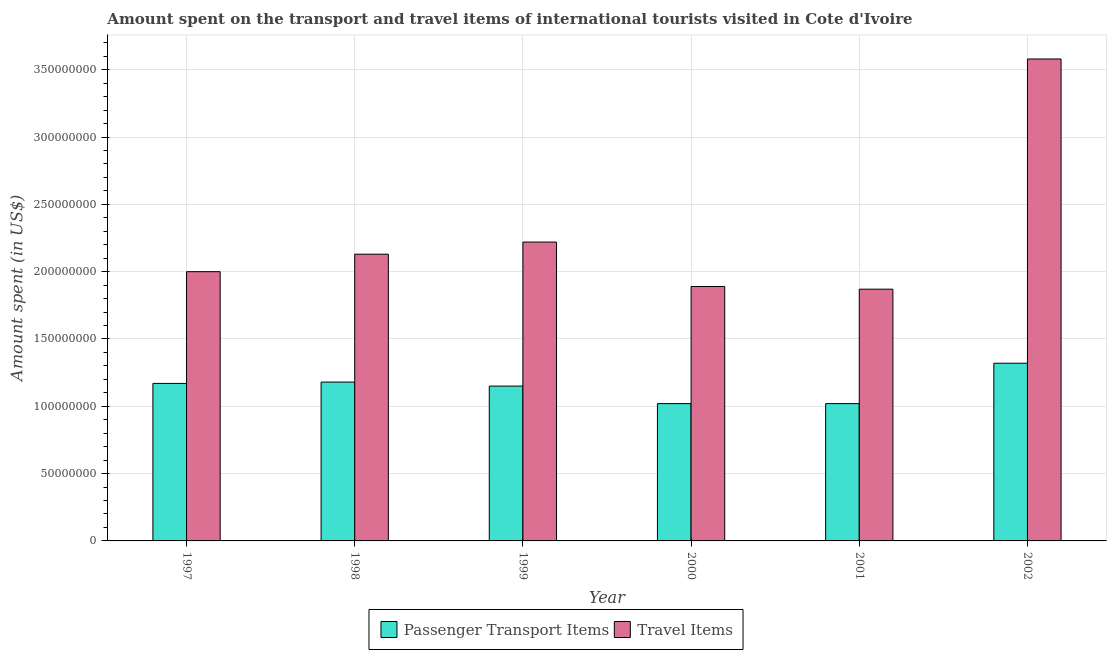How many different coloured bars are there?
Provide a succinct answer. 2. How many bars are there on the 1st tick from the right?
Keep it short and to the point. 2. What is the label of the 6th group of bars from the left?
Ensure brevity in your answer.  2002. What is the amount spent in travel items in 2002?
Your answer should be compact. 3.58e+08. Across all years, what is the maximum amount spent on passenger transport items?
Ensure brevity in your answer.  1.32e+08. Across all years, what is the minimum amount spent on passenger transport items?
Give a very brief answer. 1.02e+08. In which year was the amount spent on passenger transport items maximum?
Make the answer very short. 2002. In which year was the amount spent on passenger transport items minimum?
Ensure brevity in your answer.  2000. What is the total amount spent in travel items in the graph?
Provide a short and direct response. 1.37e+09. What is the difference between the amount spent on passenger transport items in 1997 and that in 1999?
Your response must be concise. 2.00e+06. What is the difference between the amount spent on passenger transport items in 2001 and the amount spent in travel items in 2002?
Offer a terse response. -3.00e+07. What is the average amount spent on passenger transport items per year?
Your answer should be compact. 1.14e+08. What is the ratio of the amount spent on passenger transport items in 1997 to that in 2000?
Provide a short and direct response. 1.15. What is the difference between the highest and the second highest amount spent on passenger transport items?
Your answer should be very brief. 1.40e+07. What is the difference between the highest and the lowest amount spent on passenger transport items?
Offer a very short reply. 3.00e+07. In how many years, is the amount spent in travel items greater than the average amount spent in travel items taken over all years?
Give a very brief answer. 1. What does the 1st bar from the left in 2001 represents?
Offer a very short reply. Passenger Transport Items. What does the 2nd bar from the right in 2001 represents?
Provide a succinct answer. Passenger Transport Items. How many bars are there?
Your answer should be compact. 12. Are all the bars in the graph horizontal?
Your answer should be very brief. No. How many years are there in the graph?
Your response must be concise. 6. What is the difference between two consecutive major ticks on the Y-axis?
Make the answer very short. 5.00e+07. Does the graph contain grids?
Ensure brevity in your answer.  Yes. Where does the legend appear in the graph?
Your response must be concise. Bottom center. How are the legend labels stacked?
Offer a terse response. Horizontal. What is the title of the graph?
Your response must be concise. Amount spent on the transport and travel items of international tourists visited in Cote d'Ivoire. Does "Time to import" appear as one of the legend labels in the graph?
Provide a succinct answer. No. What is the label or title of the Y-axis?
Keep it short and to the point. Amount spent (in US$). What is the Amount spent (in US$) in Passenger Transport Items in 1997?
Offer a terse response. 1.17e+08. What is the Amount spent (in US$) of Travel Items in 1997?
Keep it short and to the point. 2.00e+08. What is the Amount spent (in US$) of Passenger Transport Items in 1998?
Keep it short and to the point. 1.18e+08. What is the Amount spent (in US$) in Travel Items in 1998?
Ensure brevity in your answer.  2.13e+08. What is the Amount spent (in US$) of Passenger Transport Items in 1999?
Offer a terse response. 1.15e+08. What is the Amount spent (in US$) of Travel Items in 1999?
Offer a very short reply. 2.22e+08. What is the Amount spent (in US$) of Passenger Transport Items in 2000?
Give a very brief answer. 1.02e+08. What is the Amount spent (in US$) of Travel Items in 2000?
Make the answer very short. 1.89e+08. What is the Amount spent (in US$) of Passenger Transport Items in 2001?
Keep it short and to the point. 1.02e+08. What is the Amount spent (in US$) in Travel Items in 2001?
Offer a very short reply. 1.87e+08. What is the Amount spent (in US$) of Passenger Transport Items in 2002?
Your response must be concise. 1.32e+08. What is the Amount spent (in US$) of Travel Items in 2002?
Offer a terse response. 3.58e+08. Across all years, what is the maximum Amount spent (in US$) of Passenger Transport Items?
Offer a terse response. 1.32e+08. Across all years, what is the maximum Amount spent (in US$) of Travel Items?
Ensure brevity in your answer.  3.58e+08. Across all years, what is the minimum Amount spent (in US$) of Passenger Transport Items?
Give a very brief answer. 1.02e+08. Across all years, what is the minimum Amount spent (in US$) of Travel Items?
Provide a succinct answer. 1.87e+08. What is the total Amount spent (in US$) in Passenger Transport Items in the graph?
Provide a short and direct response. 6.86e+08. What is the total Amount spent (in US$) of Travel Items in the graph?
Offer a very short reply. 1.37e+09. What is the difference between the Amount spent (in US$) in Passenger Transport Items in 1997 and that in 1998?
Offer a very short reply. -1.00e+06. What is the difference between the Amount spent (in US$) in Travel Items in 1997 and that in 1998?
Your response must be concise. -1.30e+07. What is the difference between the Amount spent (in US$) of Passenger Transport Items in 1997 and that in 1999?
Give a very brief answer. 2.00e+06. What is the difference between the Amount spent (in US$) of Travel Items in 1997 and that in 1999?
Your answer should be compact. -2.20e+07. What is the difference between the Amount spent (in US$) of Passenger Transport Items in 1997 and that in 2000?
Keep it short and to the point. 1.50e+07. What is the difference between the Amount spent (in US$) of Travel Items in 1997 and that in 2000?
Your answer should be compact. 1.10e+07. What is the difference between the Amount spent (in US$) of Passenger Transport Items in 1997 and that in 2001?
Provide a short and direct response. 1.50e+07. What is the difference between the Amount spent (in US$) of Travel Items in 1997 and that in 2001?
Make the answer very short. 1.30e+07. What is the difference between the Amount spent (in US$) in Passenger Transport Items in 1997 and that in 2002?
Your response must be concise. -1.50e+07. What is the difference between the Amount spent (in US$) of Travel Items in 1997 and that in 2002?
Provide a short and direct response. -1.58e+08. What is the difference between the Amount spent (in US$) in Travel Items in 1998 and that in 1999?
Your answer should be compact. -9.00e+06. What is the difference between the Amount spent (in US$) of Passenger Transport Items in 1998 and that in 2000?
Provide a succinct answer. 1.60e+07. What is the difference between the Amount spent (in US$) of Travel Items in 1998 and that in 2000?
Ensure brevity in your answer.  2.40e+07. What is the difference between the Amount spent (in US$) of Passenger Transport Items in 1998 and that in 2001?
Provide a short and direct response. 1.60e+07. What is the difference between the Amount spent (in US$) of Travel Items in 1998 and that in 2001?
Keep it short and to the point. 2.60e+07. What is the difference between the Amount spent (in US$) in Passenger Transport Items in 1998 and that in 2002?
Ensure brevity in your answer.  -1.40e+07. What is the difference between the Amount spent (in US$) of Travel Items in 1998 and that in 2002?
Offer a terse response. -1.45e+08. What is the difference between the Amount spent (in US$) of Passenger Transport Items in 1999 and that in 2000?
Your answer should be compact. 1.30e+07. What is the difference between the Amount spent (in US$) in Travel Items in 1999 and that in 2000?
Your answer should be compact. 3.30e+07. What is the difference between the Amount spent (in US$) of Passenger Transport Items in 1999 and that in 2001?
Keep it short and to the point. 1.30e+07. What is the difference between the Amount spent (in US$) of Travel Items in 1999 and that in 2001?
Keep it short and to the point. 3.50e+07. What is the difference between the Amount spent (in US$) of Passenger Transport Items in 1999 and that in 2002?
Provide a succinct answer. -1.70e+07. What is the difference between the Amount spent (in US$) of Travel Items in 1999 and that in 2002?
Your answer should be very brief. -1.36e+08. What is the difference between the Amount spent (in US$) in Passenger Transport Items in 2000 and that in 2001?
Your answer should be compact. 0. What is the difference between the Amount spent (in US$) of Travel Items in 2000 and that in 2001?
Provide a succinct answer. 2.00e+06. What is the difference between the Amount spent (in US$) in Passenger Transport Items in 2000 and that in 2002?
Offer a very short reply. -3.00e+07. What is the difference between the Amount spent (in US$) of Travel Items in 2000 and that in 2002?
Your response must be concise. -1.69e+08. What is the difference between the Amount spent (in US$) of Passenger Transport Items in 2001 and that in 2002?
Your response must be concise. -3.00e+07. What is the difference between the Amount spent (in US$) of Travel Items in 2001 and that in 2002?
Make the answer very short. -1.71e+08. What is the difference between the Amount spent (in US$) of Passenger Transport Items in 1997 and the Amount spent (in US$) of Travel Items in 1998?
Keep it short and to the point. -9.60e+07. What is the difference between the Amount spent (in US$) of Passenger Transport Items in 1997 and the Amount spent (in US$) of Travel Items in 1999?
Keep it short and to the point. -1.05e+08. What is the difference between the Amount spent (in US$) of Passenger Transport Items in 1997 and the Amount spent (in US$) of Travel Items in 2000?
Your response must be concise. -7.20e+07. What is the difference between the Amount spent (in US$) in Passenger Transport Items in 1997 and the Amount spent (in US$) in Travel Items in 2001?
Ensure brevity in your answer.  -7.00e+07. What is the difference between the Amount spent (in US$) in Passenger Transport Items in 1997 and the Amount spent (in US$) in Travel Items in 2002?
Give a very brief answer. -2.41e+08. What is the difference between the Amount spent (in US$) in Passenger Transport Items in 1998 and the Amount spent (in US$) in Travel Items in 1999?
Provide a succinct answer. -1.04e+08. What is the difference between the Amount spent (in US$) in Passenger Transport Items in 1998 and the Amount spent (in US$) in Travel Items in 2000?
Make the answer very short. -7.10e+07. What is the difference between the Amount spent (in US$) of Passenger Transport Items in 1998 and the Amount spent (in US$) of Travel Items in 2001?
Provide a short and direct response. -6.90e+07. What is the difference between the Amount spent (in US$) of Passenger Transport Items in 1998 and the Amount spent (in US$) of Travel Items in 2002?
Provide a short and direct response. -2.40e+08. What is the difference between the Amount spent (in US$) of Passenger Transport Items in 1999 and the Amount spent (in US$) of Travel Items in 2000?
Offer a terse response. -7.40e+07. What is the difference between the Amount spent (in US$) in Passenger Transport Items in 1999 and the Amount spent (in US$) in Travel Items in 2001?
Ensure brevity in your answer.  -7.20e+07. What is the difference between the Amount spent (in US$) in Passenger Transport Items in 1999 and the Amount spent (in US$) in Travel Items in 2002?
Your answer should be very brief. -2.43e+08. What is the difference between the Amount spent (in US$) of Passenger Transport Items in 2000 and the Amount spent (in US$) of Travel Items in 2001?
Ensure brevity in your answer.  -8.50e+07. What is the difference between the Amount spent (in US$) of Passenger Transport Items in 2000 and the Amount spent (in US$) of Travel Items in 2002?
Give a very brief answer. -2.56e+08. What is the difference between the Amount spent (in US$) in Passenger Transport Items in 2001 and the Amount spent (in US$) in Travel Items in 2002?
Offer a very short reply. -2.56e+08. What is the average Amount spent (in US$) in Passenger Transport Items per year?
Give a very brief answer. 1.14e+08. What is the average Amount spent (in US$) in Travel Items per year?
Provide a short and direct response. 2.28e+08. In the year 1997, what is the difference between the Amount spent (in US$) in Passenger Transport Items and Amount spent (in US$) in Travel Items?
Your answer should be very brief. -8.30e+07. In the year 1998, what is the difference between the Amount spent (in US$) in Passenger Transport Items and Amount spent (in US$) in Travel Items?
Your answer should be compact. -9.50e+07. In the year 1999, what is the difference between the Amount spent (in US$) of Passenger Transport Items and Amount spent (in US$) of Travel Items?
Ensure brevity in your answer.  -1.07e+08. In the year 2000, what is the difference between the Amount spent (in US$) of Passenger Transport Items and Amount spent (in US$) of Travel Items?
Provide a short and direct response. -8.70e+07. In the year 2001, what is the difference between the Amount spent (in US$) of Passenger Transport Items and Amount spent (in US$) of Travel Items?
Your answer should be compact. -8.50e+07. In the year 2002, what is the difference between the Amount spent (in US$) in Passenger Transport Items and Amount spent (in US$) in Travel Items?
Offer a very short reply. -2.26e+08. What is the ratio of the Amount spent (in US$) in Passenger Transport Items in 1997 to that in 1998?
Give a very brief answer. 0.99. What is the ratio of the Amount spent (in US$) in Travel Items in 1997 to that in 1998?
Offer a terse response. 0.94. What is the ratio of the Amount spent (in US$) in Passenger Transport Items in 1997 to that in 1999?
Make the answer very short. 1.02. What is the ratio of the Amount spent (in US$) of Travel Items in 1997 to that in 1999?
Ensure brevity in your answer.  0.9. What is the ratio of the Amount spent (in US$) in Passenger Transport Items in 1997 to that in 2000?
Offer a very short reply. 1.15. What is the ratio of the Amount spent (in US$) of Travel Items in 1997 to that in 2000?
Your answer should be compact. 1.06. What is the ratio of the Amount spent (in US$) of Passenger Transport Items in 1997 to that in 2001?
Your response must be concise. 1.15. What is the ratio of the Amount spent (in US$) of Travel Items in 1997 to that in 2001?
Make the answer very short. 1.07. What is the ratio of the Amount spent (in US$) in Passenger Transport Items in 1997 to that in 2002?
Offer a terse response. 0.89. What is the ratio of the Amount spent (in US$) of Travel Items in 1997 to that in 2002?
Offer a very short reply. 0.56. What is the ratio of the Amount spent (in US$) in Passenger Transport Items in 1998 to that in 1999?
Provide a short and direct response. 1.03. What is the ratio of the Amount spent (in US$) in Travel Items in 1998 to that in 1999?
Provide a short and direct response. 0.96. What is the ratio of the Amount spent (in US$) in Passenger Transport Items in 1998 to that in 2000?
Keep it short and to the point. 1.16. What is the ratio of the Amount spent (in US$) in Travel Items in 1998 to that in 2000?
Give a very brief answer. 1.13. What is the ratio of the Amount spent (in US$) in Passenger Transport Items in 1998 to that in 2001?
Your response must be concise. 1.16. What is the ratio of the Amount spent (in US$) in Travel Items in 1998 to that in 2001?
Provide a short and direct response. 1.14. What is the ratio of the Amount spent (in US$) of Passenger Transport Items in 1998 to that in 2002?
Give a very brief answer. 0.89. What is the ratio of the Amount spent (in US$) of Travel Items in 1998 to that in 2002?
Your response must be concise. 0.59. What is the ratio of the Amount spent (in US$) of Passenger Transport Items in 1999 to that in 2000?
Your response must be concise. 1.13. What is the ratio of the Amount spent (in US$) in Travel Items in 1999 to that in 2000?
Make the answer very short. 1.17. What is the ratio of the Amount spent (in US$) of Passenger Transport Items in 1999 to that in 2001?
Your answer should be compact. 1.13. What is the ratio of the Amount spent (in US$) in Travel Items in 1999 to that in 2001?
Make the answer very short. 1.19. What is the ratio of the Amount spent (in US$) in Passenger Transport Items in 1999 to that in 2002?
Give a very brief answer. 0.87. What is the ratio of the Amount spent (in US$) of Travel Items in 1999 to that in 2002?
Your response must be concise. 0.62. What is the ratio of the Amount spent (in US$) in Passenger Transport Items in 2000 to that in 2001?
Ensure brevity in your answer.  1. What is the ratio of the Amount spent (in US$) of Travel Items in 2000 to that in 2001?
Your response must be concise. 1.01. What is the ratio of the Amount spent (in US$) in Passenger Transport Items in 2000 to that in 2002?
Offer a terse response. 0.77. What is the ratio of the Amount spent (in US$) in Travel Items in 2000 to that in 2002?
Your answer should be very brief. 0.53. What is the ratio of the Amount spent (in US$) in Passenger Transport Items in 2001 to that in 2002?
Offer a terse response. 0.77. What is the ratio of the Amount spent (in US$) of Travel Items in 2001 to that in 2002?
Offer a very short reply. 0.52. What is the difference between the highest and the second highest Amount spent (in US$) in Passenger Transport Items?
Provide a short and direct response. 1.40e+07. What is the difference between the highest and the second highest Amount spent (in US$) in Travel Items?
Your answer should be very brief. 1.36e+08. What is the difference between the highest and the lowest Amount spent (in US$) of Passenger Transport Items?
Keep it short and to the point. 3.00e+07. What is the difference between the highest and the lowest Amount spent (in US$) in Travel Items?
Give a very brief answer. 1.71e+08. 